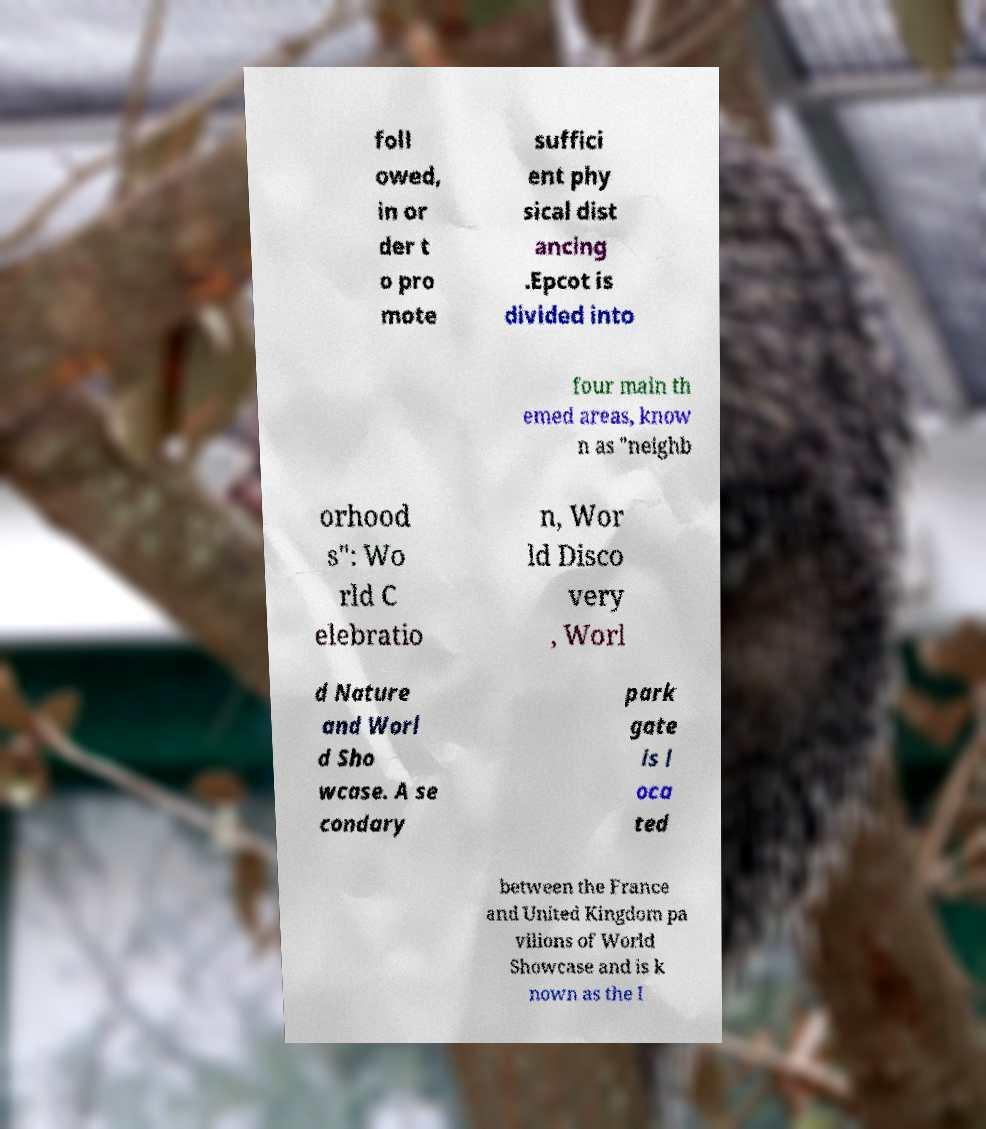Please identify and transcribe the text found in this image. foll owed, in or der t o pro mote suffici ent phy sical dist ancing .Epcot is divided into four main th emed areas, know n as "neighb orhood s": Wo rld C elebratio n, Wor ld Disco very , Worl d Nature and Worl d Sho wcase. A se condary park gate is l oca ted between the France and United Kingdom pa vilions of World Showcase and is k nown as the I 